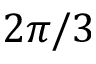<formula> <loc_0><loc_0><loc_500><loc_500>2 \pi / 3</formula> 